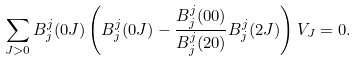<formula> <loc_0><loc_0><loc_500><loc_500>\sum _ { J > 0 } B ^ { j } _ { j } ( 0 J ) \left ( B ^ { j } _ { j } ( 0 J ) - \frac { B ^ { j } _ { j } ( 0 0 ) } { B ^ { j } _ { j } ( 2 0 ) } B ^ { j } _ { j } ( 2 J ) \right ) V _ { J } = 0 .</formula> 